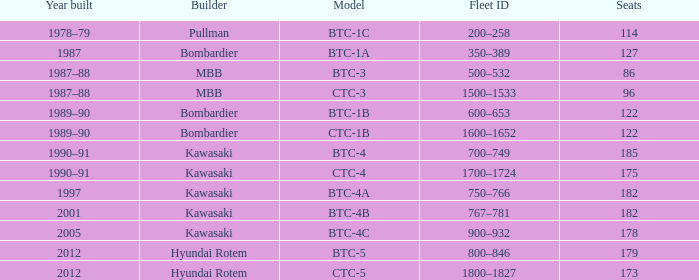Which model has 175 seats? CTC-4. 